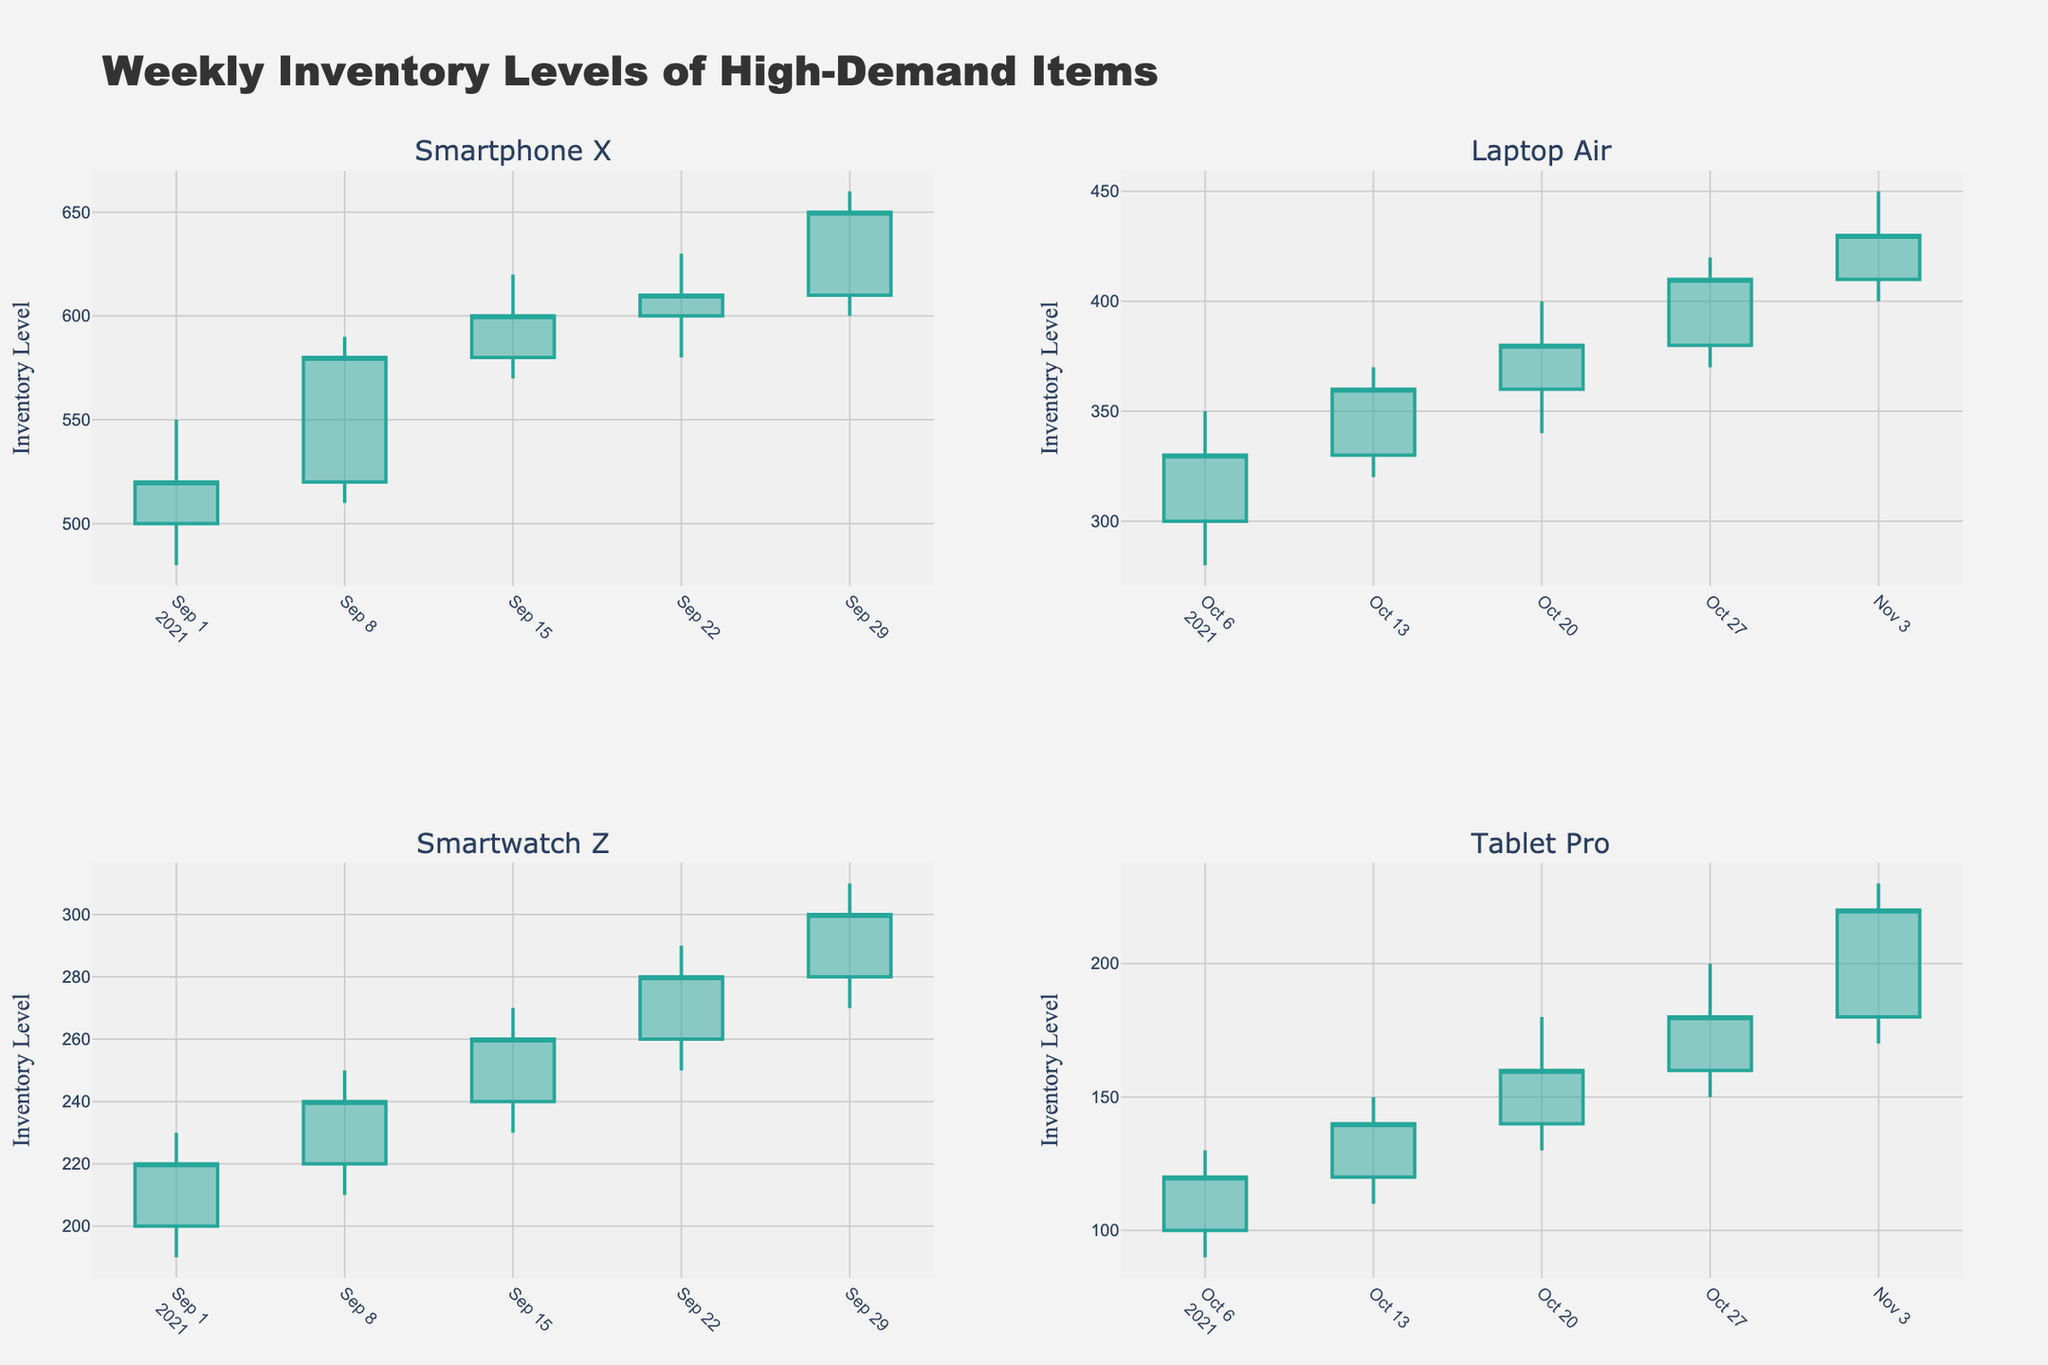What is the highest inventory level reached by "Smartphone X" by the end of September 2021? The highest inventory level is indicated by the highest value in the "High" column for "Smartphone X". The highest value for September 2021 is 660 on the week of September 29.
Answer: 660 How did the inventory level of "Laptop Air" change between the week of October 13 and October 20, 2021? To find this change, we look at the "Close" value for October 13 which is 360, and the "Open" value for October 20 which is 360. The inventories did not change between these weeks (both ended and opened at 360).
Answer: No change What is the average "Close" inventory level for "Smartwatch Z" over September 2021? To find this, sum the "Close" values for "Smartwatch Z" for September (220, 240, 260, 280, 300) and divide by 5. The sum is 1300, and 1300 divided by 5 is 260.
Answer: 260 Compare the "Low" inventory levels of "Tablet Pro" in the weeks of October 6 and October 13, 2021. For October 6th, the "Low" is 90, and for October 13th, it is 110. Since 110 is greater than 90, the inventory level was higher on October 13th.
Answer: 110 > 90 Which product had the largest range between the "High" and "Low" inventory levels in any single week? Look at the difference between "High" and "Low" for each product in each week. "Smartphone X" on September 8th has the largest range of 80 (590 - 510).
Answer: Smartphone X What trend can be observed for "Tablet Pro" from October 6 to November 3, 2021? Observing the "Close" values from October 6 (120), October 13 (140), October 20 (160), October 27 (180), and November 3 (220), the inventory level consistently increases each week.
Answer: Increasing trend Was there any week where the inventory level of "Smartwatch Z" decreased based on the "Close" values? Comparing the "Close" values week-by-week for "Smartwatch Z": August 29 (220), September 8 (240), September 15 (260), September 22 (280), September 29 (300). There were no weeks with a decrease.
Answer: No How does the trend in the inventory level of "Smartphone X" compare to "Laptop Air" in terms of consistency from September to October? "Smartphone X" shows occasional dips and rises (520 to 650 over September), indicating a volatile trend. In contrast, "Laptop Air" consistently increases from 330 at the start to 430 by early November without a dip, indicating a more stable trend.
Answer: Volatile vs Stable 